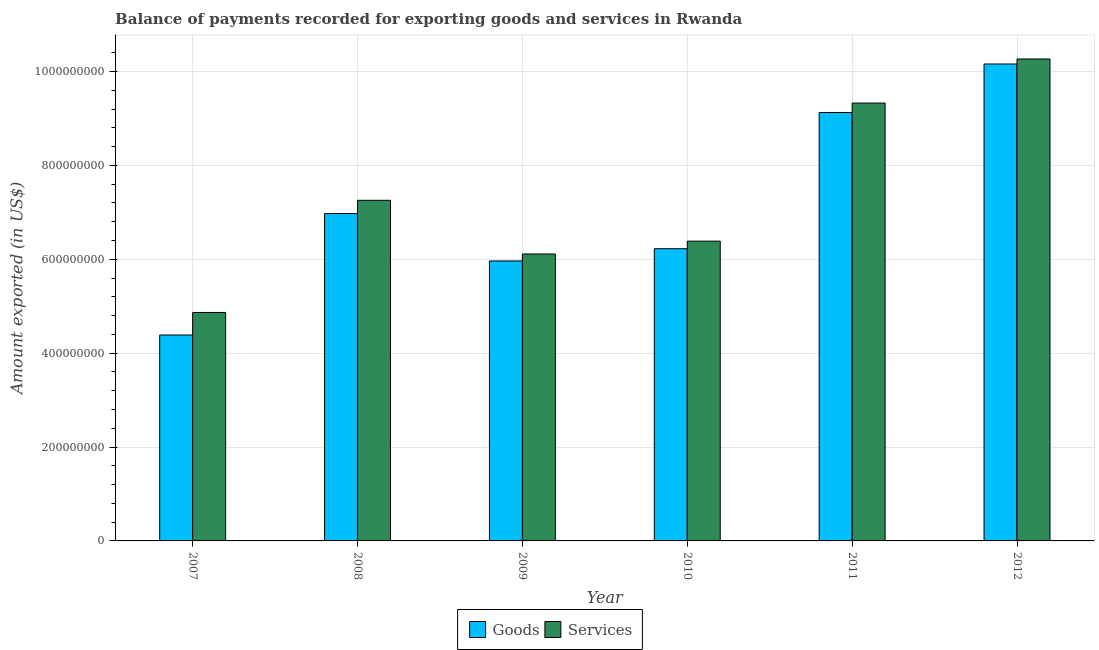How many different coloured bars are there?
Provide a short and direct response. 2. Are the number of bars on each tick of the X-axis equal?
Offer a very short reply. Yes. How many bars are there on the 1st tick from the left?
Provide a succinct answer. 2. How many bars are there on the 6th tick from the right?
Provide a succinct answer. 2. What is the label of the 4th group of bars from the left?
Provide a short and direct response. 2010. What is the amount of services exported in 2010?
Your answer should be compact. 6.39e+08. Across all years, what is the maximum amount of goods exported?
Your answer should be compact. 1.02e+09. Across all years, what is the minimum amount of goods exported?
Give a very brief answer. 4.39e+08. In which year was the amount of goods exported minimum?
Your answer should be compact. 2007. What is the total amount of goods exported in the graph?
Offer a terse response. 4.28e+09. What is the difference between the amount of goods exported in 2007 and that in 2011?
Provide a succinct answer. -4.74e+08. What is the difference between the amount of goods exported in 2011 and the amount of services exported in 2009?
Give a very brief answer. 3.16e+08. What is the average amount of goods exported per year?
Give a very brief answer. 7.14e+08. What is the ratio of the amount of services exported in 2007 to that in 2009?
Offer a very short reply. 0.8. Is the difference between the amount of goods exported in 2011 and 2012 greater than the difference between the amount of services exported in 2011 and 2012?
Make the answer very short. No. What is the difference between the highest and the second highest amount of services exported?
Provide a short and direct response. 9.39e+07. What is the difference between the highest and the lowest amount of goods exported?
Provide a short and direct response. 5.77e+08. Is the sum of the amount of goods exported in 2010 and 2011 greater than the maximum amount of services exported across all years?
Your answer should be very brief. Yes. What does the 1st bar from the left in 2012 represents?
Offer a terse response. Goods. What does the 2nd bar from the right in 2008 represents?
Give a very brief answer. Goods. How many years are there in the graph?
Make the answer very short. 6. What is the difference between two consecutive major ticks on the Y-axis?
Provide a succinct answer. 2.00e+08. How many legend labels are there?
Your answer should be compact. 2. How are the legend labels stacked?
Your answer should be very brief. Horizontal. What is the title of the graph?
Provide a succinct answer. Balance of payments recorded for exporting goods and services in Rwanda. What is the label or title of the X-axis?
Offer a very short reply. Year. What is the label or title of the Y-axis?
Make the answer very short. Amount exported (in US$). What is the Amount exported (in US$) in Goods in 2007?
Your answer should be very brief. 4.39e+08. What is the Amount exported (in US$) of Services in 2007?
Provide a succinct answer. 4.87e+08. What is the Amount exported (in US$) in Goods in 2008?
Make the answer very short. 6.97e+08. What is the Amount exported (in US$) in Services in 2008?
Keep it short and to the point. 7.26e+08. What is the Amount exported (in US$) in Goods in 2009?
Offer a very short reply. 5.96e+08. What is the Amount exported (in US$) in Services in 2009?
Your answer should be very brief. 6.11e+08. What is the Amount exported (in US$) in Goods in 2010?
Your answer should be very brief. 6.23e+08. What is the Amount exported (in US$) in Services in 2010?
Give a very brief answer. 6.39e+08. What is the Amount exported (in US$) in Goods in 2011?
Provide a succinct answer. 9.13e+08. What is the Amount exported (in US$) in Services in 2011?
Make the answer very short. 9.33e+08. What is the Amount exported (in US$) in Goods in 2012?
Provide a short and direct response. 1.02e+09. What is the Amount exported (in US$) in Services in 2012?
Keep it short and to the point. 1.03e+09. Across all years, what is the maximum Amount exported (in US$) of Goods?
Your answer should be compact. 1.02e+09. Across all years, what is the maximum Amount exported (in US$) in Services?
Offer a very short reply. 1.03e+09. Across all years, what is the minimum Amount exported (in US$) in Goods?
Ensure brevity in your answer.  4.39e+08. Across all years, what is the minimum Amount exported (in US$) in Services?
Offer a very short reply. 4.87e+08. What is the total Amount exported (in US$) in Goods in the graph?
Your response must be concise. 4.28e+09. What is the total Amount exported (in US$) of Services in the graph?
Keep it short and to the point. 4.42e+09. What is the difference between the Amount exported (in US$) in Goods in 2007 and that in 2008?
Ensure brevity in your answer.  -2.59e+08. What is the difference between the Amount exported (in US$) in Services in 2007 and that in 2008?
Give a very brief answer. -2.39e+08. What is the difference between the Amount exported (in US$) of Goods in 2007 and that in 2009?
Provide a succinct answer. -1.58e+08. What is the difference between the Amount exported (in US$) of Services in 2007 and that in 2009?
Ensure brevity in your answer.  -1.25e+08. What is the difference between the Amount exported (in US$) of Goods in 2007 and that in 2010?
Your answer should be very brief. -1.84e+08. What is the difference between the Amount exported (in US$) of Services in 2007 and that in 2010?
Ensure brevity in your answer.  -1.52e+08. What is the difference between the Amount exported (in US$) of Goods in 2007 and that in 2011?
Your response must be concise. -4.74e+08. What is the difference between the Amount exported (in US$) in Services in 2007 and that in 2011?
Your response must be concise. -4.46e+08. What is the difference between the Amount exported (in US$) in Goods in 2007 and that in 2012?
Ensure brevity in your answer.  -5.77e+08. What is the difference between the Amount exported (in US$) in Services in 2007 and that in 2012?
Offer a very short reply. -5.40e+08. What is the difference between the Amount exported (in US$) of Goods in 2008 and that in 2009?
Your response must be concise. 1.01e+08. What is the difference between the Amount exported (in US$) of Services in 2008 and that in 2009?
Keep it short and to the point. 1.14e+08. What is the difference between the Amount exported (in US$) in Goods in 2008 and that in 2010?
Provide a succinct answer. 7.49e+07. What is the difference between the Amount exported (in US$) in Services in 2008 and that in 2010?
Make the answer very short. 8.70e+07. What is the difference between the Amount exported (in US$) of Goods in 2008 and that in 2011?
Your answer should be compact. -2.15e+08. What is the difference between the Amount exported (in US$) in Services in 2008 and that in 2011?
Your response must be concise. -2.07e+08. What is the difference between the Amount exported (in US$) of Goods in 2008 and that in 2012?
Offer a very short reply. -3.19e+08. What is the difference between the Amount exported (in US$) in Services in 2008 and that in 2012?
Your response must be concise. -3.01e+08. What is the difference between the Amount exported (in US$) of Goods in 2009 and that in 2010?
Keep it short and to the point. -2.61e+07. What is the difference between the Amount exported (in US$) in Services in 2009 and that in 2010?
Your answer should be compact. -2.73e+07. What is the difference between the Amount exported (in US$) of Goods in 2009 and that in 2011?
Ensure brevity in your answer.  -3.16e+08. What is the difference between the Amount exported (in US$) of Services in 2009 and that in 2011?
Ensure brevity in your answer.  -3.22e+08. What is the difference between the Amount exported (in US$) of Goods in 2009 and that in 2012?
Provide a short and direct response. -4.20e+08. What is the difference between the Amount exported (in US$) in Services in 2009 and that in 2012?
Your answer should be very brief. -4.15e+08. What is the difference between the Amount exported (in US$) in Goods in 2010 and that in 2011?
Offer a terse response. -2.90e+08. What is the difference between the Amount exported (in US$) in Services in 2010 and that in 2011?
Provide a succinct answer. -2.94e+08. What is the difference between the Amount exported (in US$) of Goods in 2010 and that in 2012?
Your response must be concise. -3.94e+08. What is the difference between the Amount exported (in US$) of Services in 2010 and that in 2012?
Your response must be concise. -3.88e+08. What is the difference between the Amount exported (in US$) in Goods in 2011 and that in 2012?
Keep it short and to the point. -1.03e+08. What is the difference between the Amount exported (in US$) of Services in 2011 and that in 2012?
Keep it short and to the point. -9.39e+07. What is the difference between the Amount exported (in US$) in Goods in 2007 and the Amount exported (in US$) in Services in 2008?
Provide a short and direct response. -2.87e+08. What is the difference between the Amount exported (in US$) in Goods in 2007 and the Amount exported (in US$) in Services in 2009?
Your answer should be very brief. -1.73e+08. What is the difference between the Amount exported (in US$) of Goods in 2007 and the Amount exported (in US$) of Services in 2010?
Keep it short and to the point. -2.00e+08. What is the difference between the Amount exported (in US$) of Goods in 2007 and the Amount exported (in US$) of Services in 2011?
Ensure brevity in your answer.  -4.94e+08. What is the difference between the Amount exported (in US$) in Goods in 2007 and the Amount exported (in US$) in Services in 2012?
Ensure brevity in your answer.  -5.88e+08. What is the difference between the Amount exported (in US$) in Goods in 2008 and the Amount exported (in US$) in Services in 2009?
Make the answer very short. 8.61e+07. What is the difference between the Amount exported (in US$) in Goods in 2008 and the Amount exported (in US$) in Services in 2010?
Provide a succinct answer. 5.88e+07. What is the difference between the Amount exported (in US$) in Goods in 2008 and the Amount exported (in US$) in Services in 2011?
Ensure brevity in your answer.  -2.35e+08. What is the difference between the Amount exported (in US$) of Goods in 2008 and the Amount exported (in US$) of Services in 2012?
Your answer should be very brief. -3.29e+08. What is the difference between the Amount exported (in US$) in Goods in 2009 and the Amount exported (in US$) in Services in 2010?
Your answer should be compact. -4.22e+07. What is the difference between the Amount exported (in US$) of Goods in 2009 and the Amount exported (in US$) of Services in 2011?
Provide a short and direct response. -3.36e+08. What is the difference between the Amount exported (in US$) in Goods in 2009 and the Amount exported (in US$) in Services in 2012?
Make the answer very short. -4.30e+08. What is the difference between the Amount exported (in US$) of Goods in 2010 and the Amount exported (in US$) of Services in 2011?
Offer a very short reply. -3.10e+08. What is the difference between the Amount exported (in US$) in Goods in 2010 and the Amount exported (in US$) in Services in 2012?
Offer a very short reply. -4.04e+08. What is the difference between the Amount exported (in US$) of Goods in 2011 and the Amount exported (in US$) of Services in 2012?
Offer a terse response. -1.14e+08. What is the average Amount exported (in US$) of Goods per year?
Your answer should be compact. 7.14e+08. What is the average Amount exported (in US$) of Services per year?
Keep it short and to the point. 7.37e+08. In the year 2007, what is the difference between the Amount exported (in US$) of Goods and Amount exported (in US$) of Services?
Provide a short and direct response. -4.80e+07. In the year 2008, what is the difference between the Amount exported (in US$) of Goods and Amount exported (in US$) of Services?
Make the answer very short. -2.83e+07. In the year 2009, what is the difference between the Amount exported (in US$) of Goods and Amount exported (in US$) of Services?
Keep it short and to the point. -1.49e+07. In the year 2010, what is the difference between the Amount exported (in US$) in Goods and Amount exported (in US$) in Services?
Provide a succinct answer. -1.61e+07. In the year 2011, what is the difference between the Amount exported (in US$) of Goods and Amount exported (in US$) of Services?
Offer a terse response. -2.01e+07. In the year 2012, what is the difference between the Amount exported (in US$) of Goods and Amount exported (in US$) of Services?
Keep it short and to the point. -1.07e+07. What is the ratio of the Amount exported (in US$) in Goods in 2007 to that in 2008?
Your response must be concise. 0.63. What is the ratio of the Amount exported (in US$) in Services in 2007 to that in 2008?
Offer a very short reply. 0.67. What is the ratio of the Amount exported (in US$) in Goods in 2007 to that in 2009?
Ensure brevity in your answer.  0.74. What is the ratio of the Amount exported (in US$) in Services in 2007 to that in 2009?
Your response must be concise. 0.8. What is the ratio of the Amount exported (in US$) of Goods in 2007 to that in 2010?
Offer a very short reply. 0.7. What is the ratio of the Amount exported (in US$) in Services in 2007 to that in 2010?
Make the answer very short. 0.76. What is the ratio of the Amount exported (in US$) of Goods in 2007 to that in 2011?
Offer a very short reply. 0.48. What is the ratio of the Amount exported (in US$) in Services in 2007 to that in 2011?
Offer a very short reply. 0.52. What is the ratio of the Amount exported (in US$) in Goods in 2007 to that in 2012?
Offer a very short reply. 0.43. What is the ratio of the Amount exported (in US$) of Services in 2007 to that in 2012?
Your answer should be very brief. 0.47. What is the ratio of the Amount exported (in US$) in Goods in 2008 to that in 2009?
Provide a short and direct response. 1.17. What is the ratio of the Amount exported (in US$) of Services in 2008 to that in 2009?
Your response must be concise. 1.19. What is the ratio of the Amount exported (in US$) of Goods in 2008 to that in 2010?
Offer a very short reply. 1.12. What is the ratio of the Amount exported (in US$) in Services in 2008 to that in 2010?
Provide a short and direct response. 1.14. What is the ratio of the Amount exported (in US$) of Goods in 2008 to that in 2011?
Offer a very short reply. 0.76. What is the ratio of the Amount exported (in US$) in Services in 2008 to that in 2011?
Offer a very short reply. 0.78. What is the ratio of the Amount exported (in US$) in Goods in 2008 to that in 2012?
Ensure brevity in your answer.  0.69. What is the ratio of the Amount exported (in US$) in Services in 2008 to that in 2012?
Provide a short and direct response. 0.71. What is the ratio of the Amount exported (in US$) of Goods in 2009 to that in 2010?
Your response must be concise. 0.96. What is the ratio of the Amount exported (in US$) of Services in 2009 to that in 2010?
Your answer should be very brief. 0.96. What is the ratio of the Amount exported (in US$) in Goods in 2009 to that in 2011?
Provide a succinct answer. 0.65. What is the ratio of the Amount exported (in US$) of Services in 2009 to that in 2011?
Ensure brevity in your answer.  0.66. What is the ratio of the Amount exported (in US$) in Goods in 2009 to that in 2012?
Ensure brevity in your answer.  0.59. What is the ratio of the Amount exported (in US$) in Services in 2009 to that in 2012?
Your answer should be very brief. 0.6. What is the ratio of the Amount exported (in US$) of Goods in 2010 to that in 2011?
Keep it short and to the point. 0.68. What is the ratio of the Amount exported (in US$) in Services in 2010 to that in 2011?
Your response must be concise. 0.68. What is the ratio of the Amount exported (in US$) in Goods in 2010 to that in 2012?
Make the answer very short. 0.61. What is the ratio of the Amount exported (in US$) of Services in 2010 to that in 2012?
Your response must be concise. 0.62. What is the ratio of the Amount exported (in US$) in Goods in 2011 to that in 2012?
Offer a very short reply. 0.9. What is the ratio of the Amount exported (in US$) in Services in 2011 to that in 2012?
Your answer should be very brief. 0.91. What is the difference between the highest and the second highest Amount exported (in US$) of Goods?
Keep it short and to the point. 1.03e+08. What is the difference between the highest and the second highest Amount exported (in US$) in Services?
Your answer should be very brief. 9.39e+07. What is the difference between the highest and the lowest Amount exported (in US$) in Goods?
Provide a short and direct response. 5.77e+08. What is the difference between the highest and the lowest Amount exported (in US$) in Services?
Your answer should be compact. 5.40e+08. 